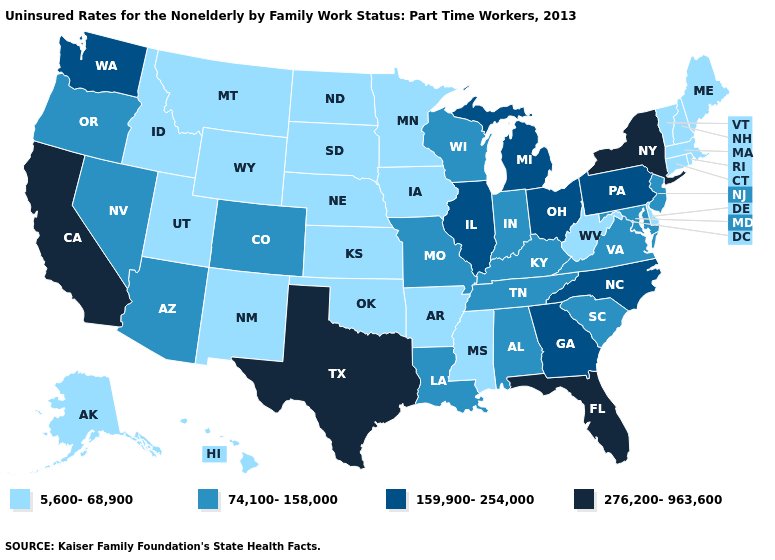Among the states that border New Mexico , does Colorado have the lowest value?
Be succinct. No. Which states have the lowest value in the South?
Short answer required. Arkansas, Delaware, Mississippi, Oklahoma, West Virginia. What is the value of Oklahoma?
Write a very short answer. 5,600-68,900. Which states have the lowest value in the West?
Quick response, please. Alaska, Hawaii, Idaho, Montana, New Mexico, Utah, Wyoming. What is the value of Michigan?
Concise answer only. 159,900-254,000. Does Vermont have the highest value in the USA?
Be succinct. No. What is the value of Mississippi?
Keep it brief. 5,600-68,900. Does Wyoming have the lowest value in the West?
Give a very brief answer. Yes. Which states have the lowest value in the USA?
Keep it brief. Alaska, Arkansas, Connecticut, Delaware, Hawaii, Idaho, Iowa, Kansas, Maine, Massachusetts, Minnesota, Mississippi, Montana, Nebraska, New Hampshire, New Mexico, North Dakota, Oklahoma, Rhode Island, South Dakota, Utah, Vermont, West Virginia, Wyoming. What is the value of Idaho?
Give a very brief answer. 5,600-68,900. Name the states that have a value in the range 159,900-254,000?
Give a very brief answer. Georgia, Illinois, Michigan, North Carolina, Ohio, Pennsylvania, Washington. Does the first symbol in the legend represent the smallest category?
Concise answer only. Yes. Does Tennessee have a lower value than Washington?
Concise answer only. Yes. Does the first symbol in the legend represent the smallest category?
Short answer required. Yes. Does Tennessee have a higher value than Nevada?
Write a very short answer. No. 